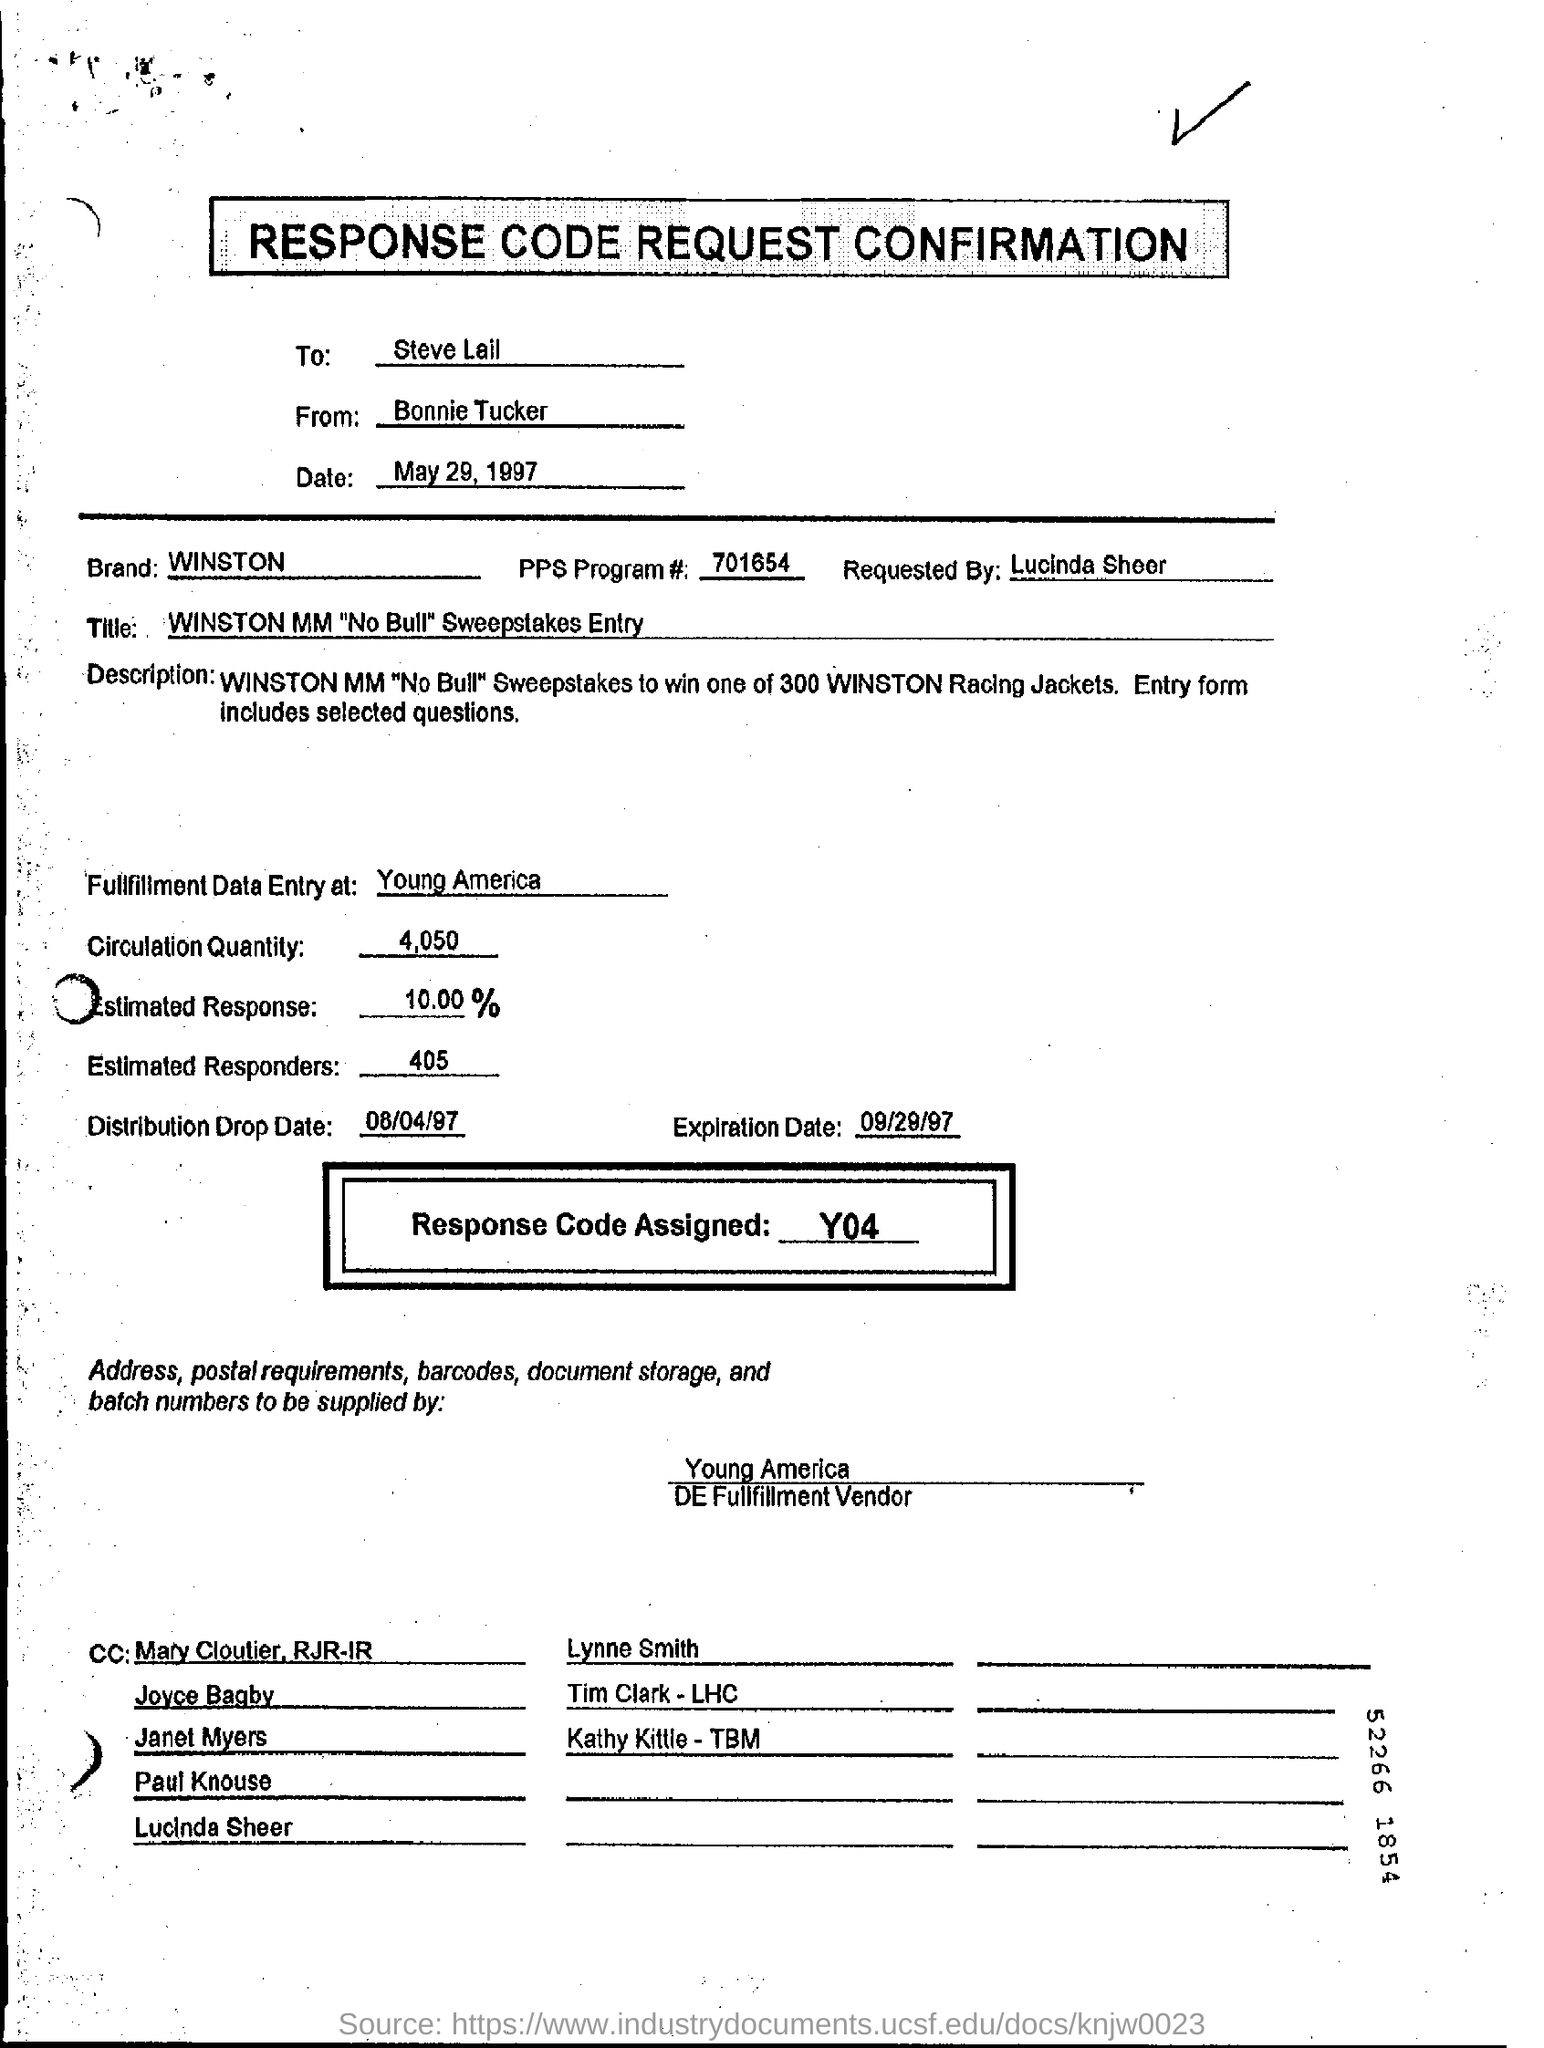Outline some significant characteristics in this image. The PPs Program # is 701654... The request was made by Lucinda Sheer. The speaker is inquiring about the location of the fulfillment data entry for Young America. The brand is Winston. The sender of this message is Bonnie Tucker. 